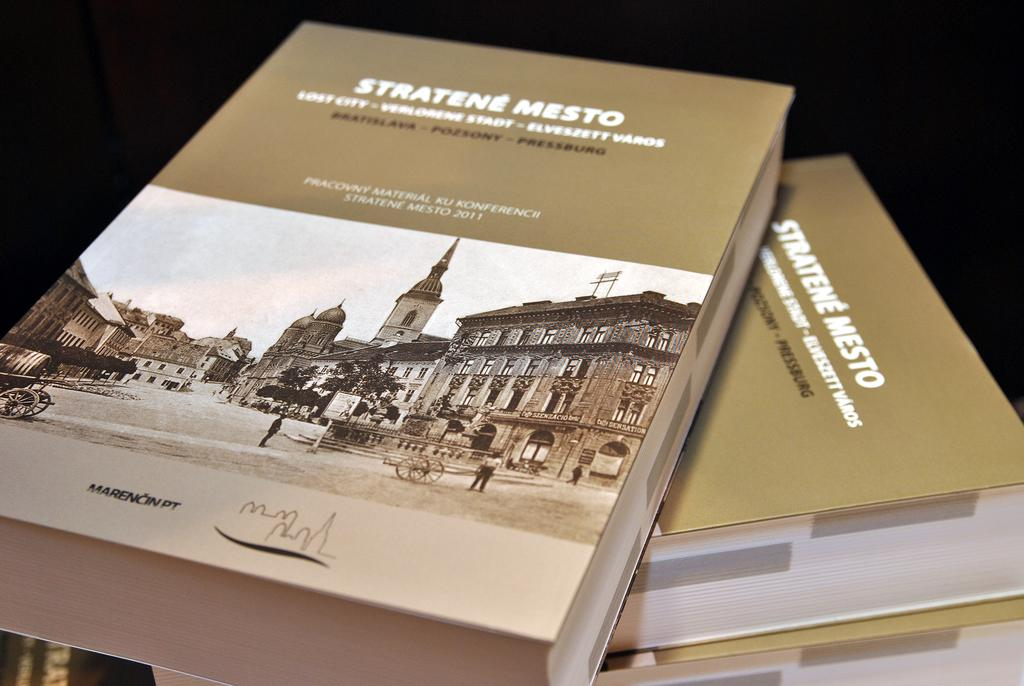<image>
Provide a brief description of the given image. a book with the title 'stratene mesto' on it 